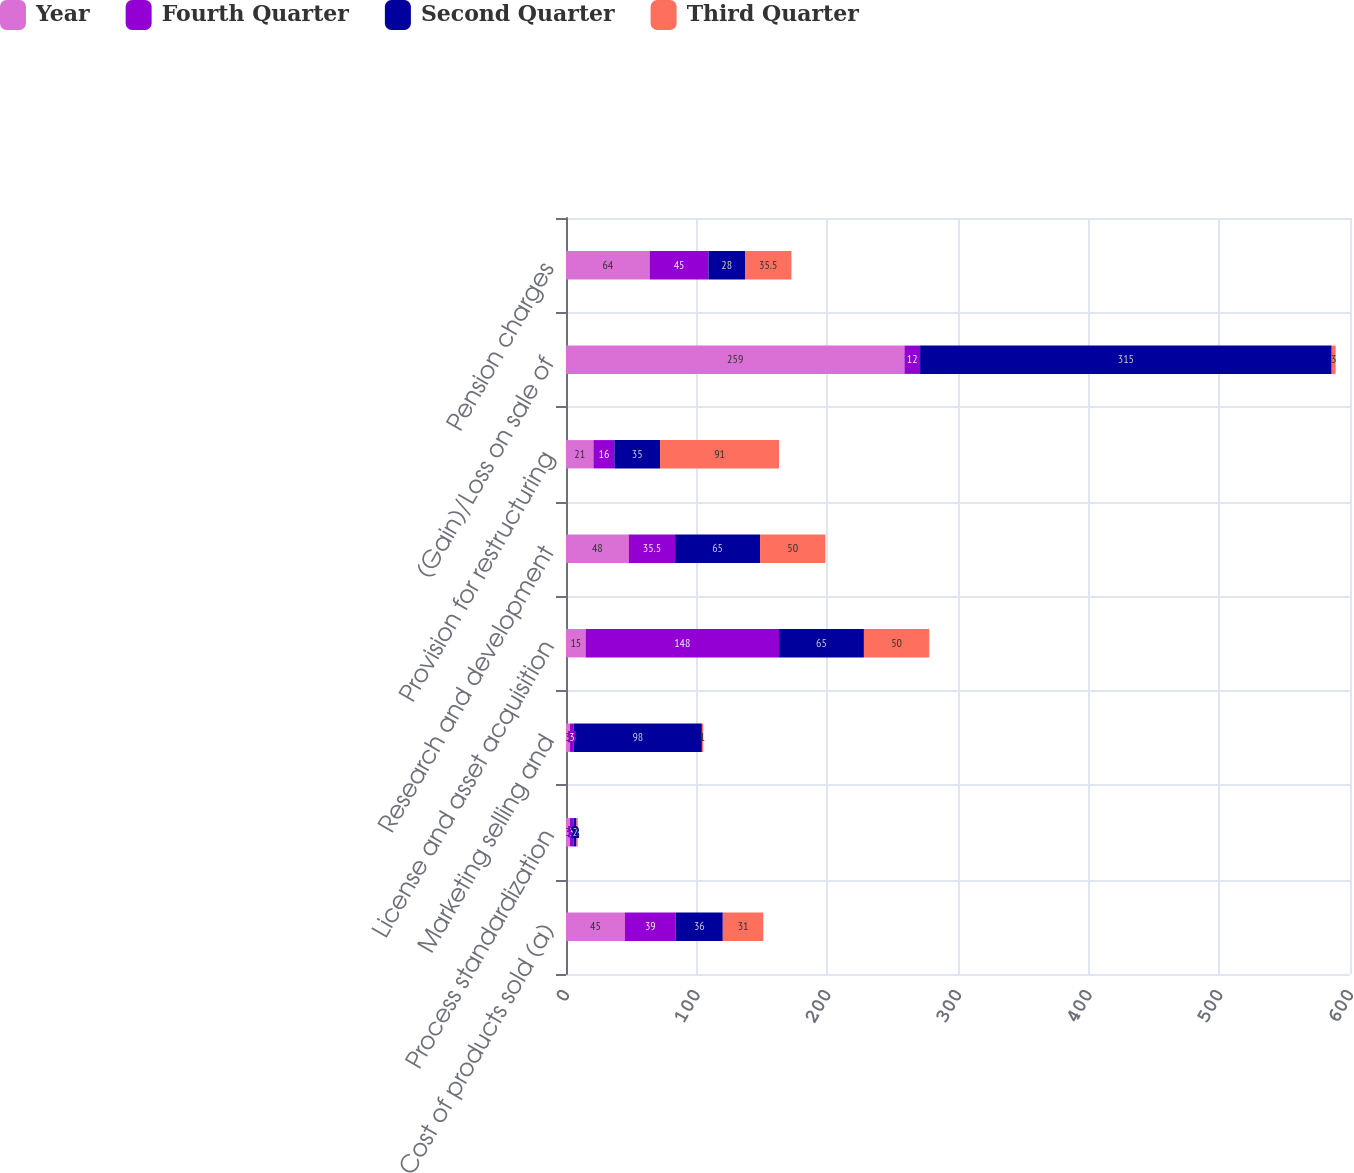Convert chart to OTSL. <chart><loc_0><loc_0><loc_500><loc_500><stacked_bar_chart><ecel><fcel>Cost of products sold (a)<fcel>Process standardization<fcel>Marketing selling and<fcel>License and asset acquisition<fcel>Research and development<fcel>Provision for restructuring<fcel>(Gain)/Loss on sale of<fcel>Pension charges<nl><fcel>Year<fcel>45<fcel>3<fcel>3<fcel>15<fcel>48<fcel>21<fcel>259<fcel>64<nl><fcel>Fourth Quarter<fcel>39<fcel>3<fcel>3<fcel>148<fcel>35.5<fcel>16<fcel>12<fcel>45<nl><fcel>Second Quarter<fcel>36<fcel>2<fcel>98<fcel>65<fcel>65<fcel>35<fcel>315<fcel>28<nl><fcel>Third Quarter<fcel>31<fcel>1<fcel>1<fcel>50<fcel>50<fcel>91<fcel>3<fcel>35.5<nl></chart> 